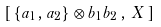Convert formula to latex. <formula><loc_0><loc_0><loc_500><loc_500>\left [ \, \{ a _ { 1 } , a _ { 2 } \} \otimes b _ { 1 } b _ { 2 } \, , \, X \, \right ]</formula> 